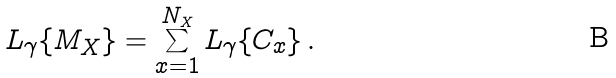<formula> <loc_0><loc_0><loc_500><loc_500>L _ { \gamma } \{ M _ { X } \} = \sum _ { x = 1 } ^ { N _ { X } } L _ { \gamma } \{ C _ { x } \} \, .</formula> 